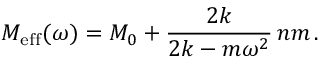<formula> <loc_0><loc_0><loc_500><loc_500>M _ { e f f } ( \omega ) = M _ { 0 } + \frac { 2 k } { 2 k - m \omega ^ { 2 } } \, n m \, .</formula> 